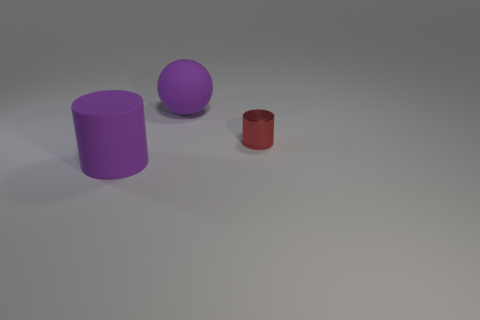Add 1 tiny cyan metal blocks. How many objects exist? 4 Subtract all cylinders. How many objects are left? 1 Add 2 large yellow objects. How many large yellow objects exist? 2 Subtract 0 gray balls. How many objects are left? 3 Subtract all big purple objects. Subtract all purple shiny things. How many objects are left? 1 Add 3 purple balls. How many purple balls are left? 4 